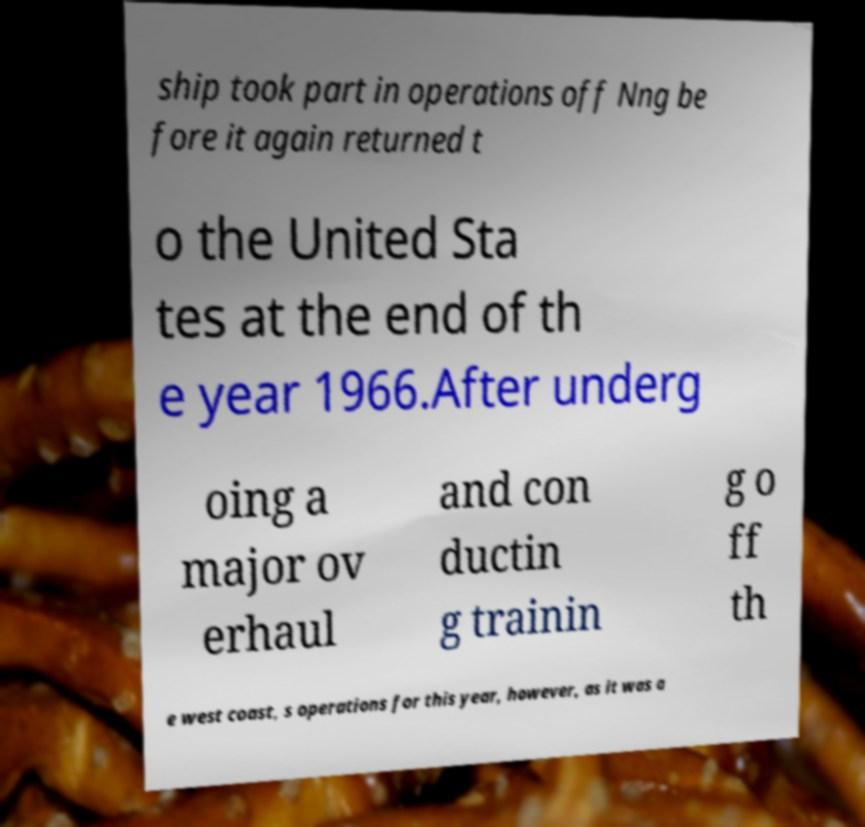For documentation purposes, I need the text within this image transcribed. Could you provide that? ship took part in operations off Nng be fore it again returned t o the United Sta tes at the end of th e year 1966.After underg oing a major ov erhaul and con ductin g trainin g o ff th e west coast, s operations for this year, however, as it was a 